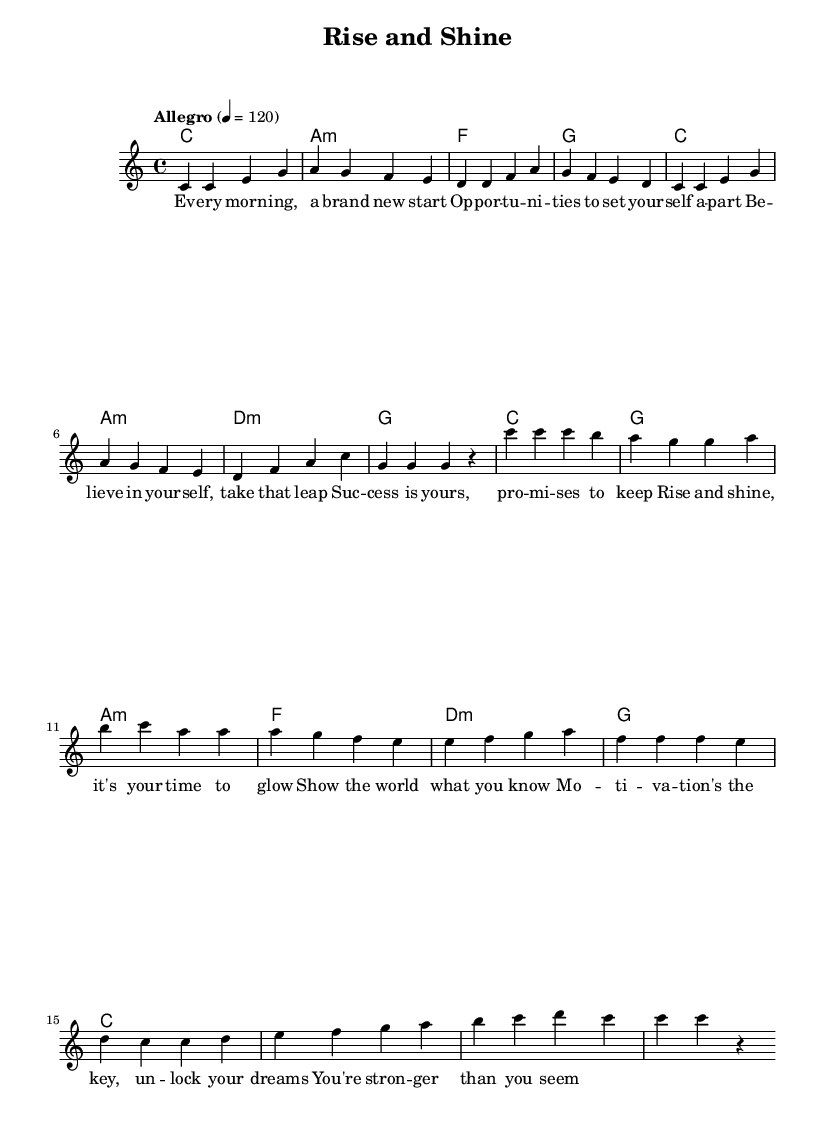What is the key signature of this music? The key signature is indicated at the beginning of the sheet music and it shows no sharps or flats, which corresponds to C major.
Answer: C major What is the time signature of this music? The time signature is displayed at the beginning of the score, showing a pattern of 4 beats per measure, which is represented as 4/4.
Answer: 4/4 What is the tempo marking for this piece? The tempo marking is given as "Allegro," with a specific beat of 120 indicating a fast pace, typically associated with lively music.
Answer: Allegro How many measures are there in the chorus section? By counting the measures in the chorus, which starts right after the verse, there are 8 measures in total.
Answer: 8 What is the first note of the melody? The first note of the melody in the sheet music is a C, which can be identified as the first note written in the melody line.
Answer: C Which chord follows the first measure of the verse? In the sheet music, the first measure of the verse is a "C" chord, as indicated by the chord symbols written above the staff.
Answer: C How many times is the word “success” mentioned in the lyrics? In the lyrics, the word "success" appears once; this can be identified by reading through the provided text below the melody.
Answer: Once 